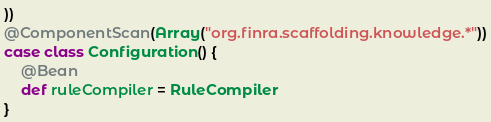<code> <loc_0><loc_0><loc_500><loc_500><_Scala_>))
@ComponentScan(Array("org.finra.scaffolding.knowledge.*"))
case class Configuration() {
    @Bean
    def ruleCompiler = RuleCompiler
}
</code> 